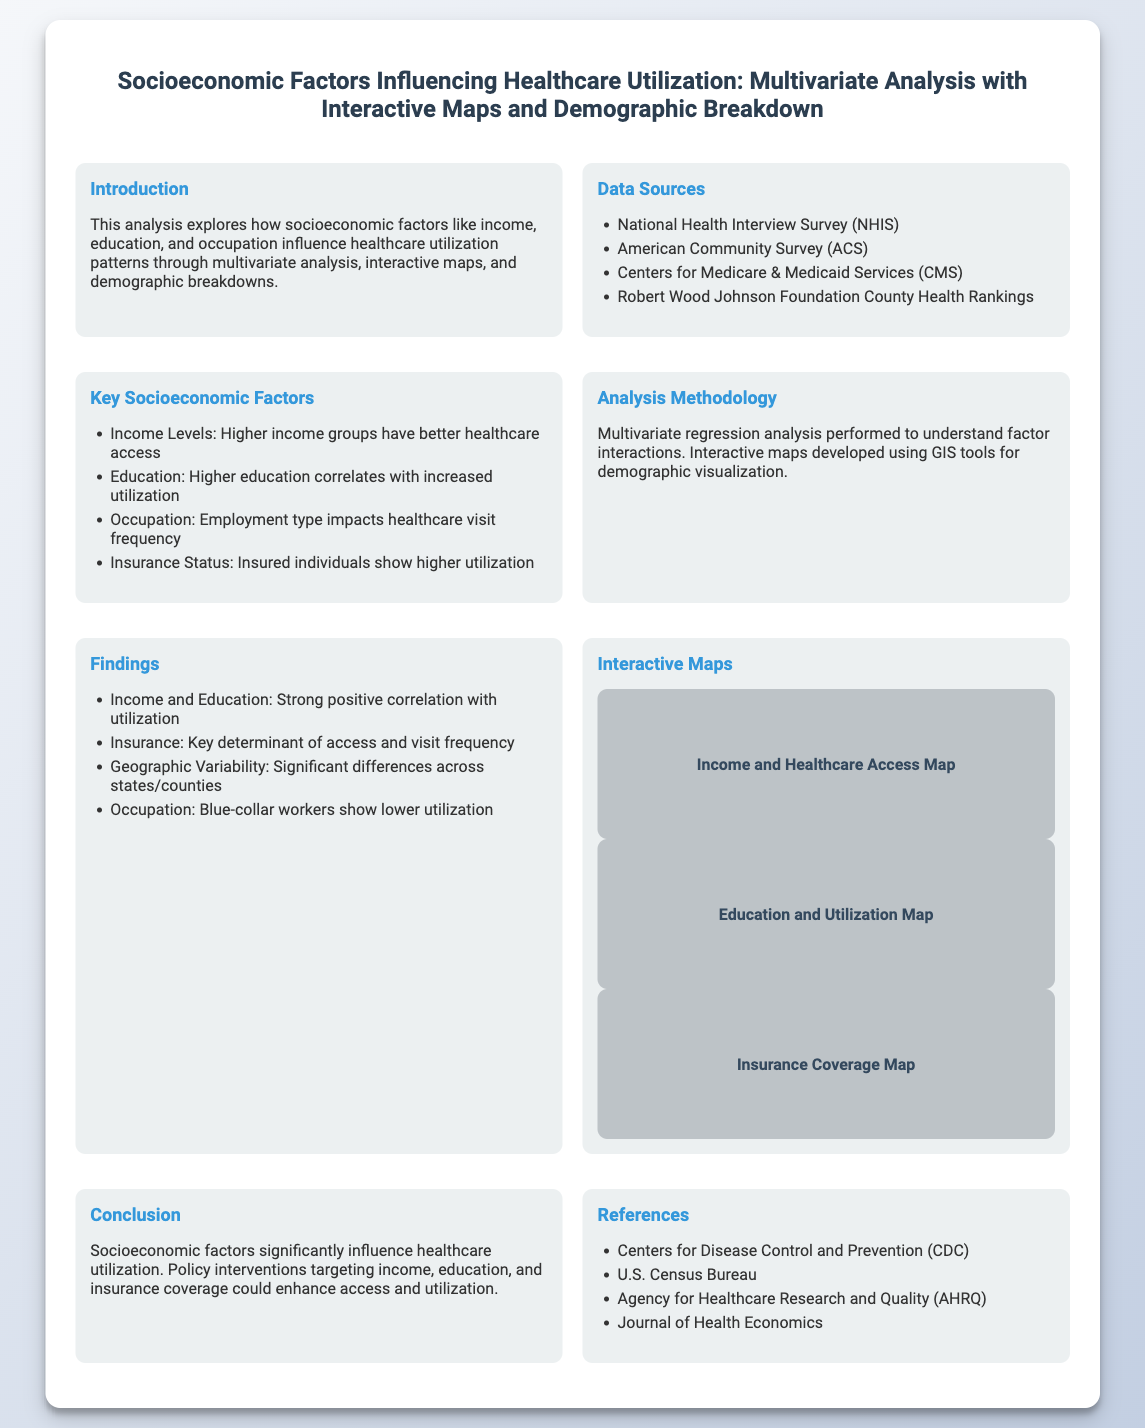what is the title of the presentation? The title of the presentation is stated at the top of the document, summarizing the main theme of the analysis.
Answer: Socioeconomic Factors Influencing Healthcare Utilization: Multivariate Analysis with Interactive Maps and Demographic Breakdown which data sources are mentioned? The data sources are listed in the "Data Sources" section, providing insight into where the data was obtained for the analysis.
Answer: National Health Interview Survey (NHIS), American Community Survey (ACS), Centers for Medicare & Medicaid Services (CMS), Robert Wood Johnson Foundation County Health Rankings what are the key socioeconomic factors influencing healthcare utilization? The key socioeconomic factors are outlined in the "Key Socioeconomic Factors" section, highlighting the main elements affecting access to healthcare.
Answer: Income Levels, Education, Occupation, Insurance Status what methodology was used in the analysis? The methodology is described in the "Analysis Methodology" section, explaining how the analysis was conducted to examine the data.
Answer: Multivariate regression analysis which occupation group shows lower healthcare utilization? This information is found in the "Findings" section, discussing differences in utilization based on occupation types.
Answer: Blue-collar workers what is the purpose of the interactive maps included? The purpose is explained in the "Interactive Maps" section, indicating their role in visualizing demographic data in relation to healthcare access.
Answer: Demographic visualization what does the conclusion suggest for policy interventions? The conclusion articulates suggestions based on the analysis findings related to healthcare access improvements.
Answer: Targeting income, education, and insurance coverage how many interactive maps are presented? The number of interactive maps is mentioned in the "Interactive Maps" section, specifying the information they visually represent.
Answer: Three 